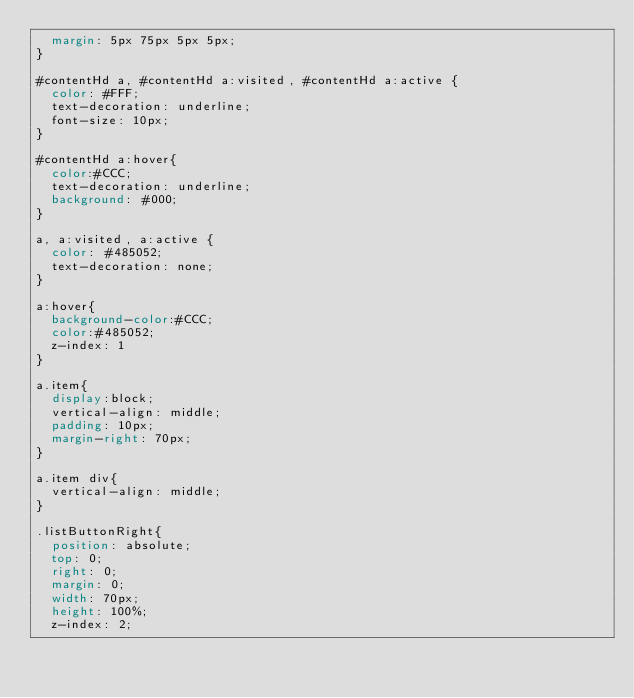Convert code to text. <code><loc_0><loc_0><loc_500><loc_500><_CSS_>	margin: 5px 75px 5px 5px;
}

#contentHd a, #contentHd a:visited, #contentHd a:active {
	color: #FFF;
	text-decoration: underline;
	font-size: 10px;
}

#contentHd a:hover{
	color:#CCC;
	text-decoration: underline;
	background: #000;
}

a, a:visited, a:active {
	color: #485052;
	text-decoration: none;
}

a:hover{
	background-color:#CCC;
	color:#485052;
	z-index: 1
}

a.item{
	display:block;
	vertical-align: middle;
	padding: 10px;
	margin-right: 70px;
}

a.item div{
	vertical-align: middle;
}

.listButtonRight{
	position: absolute;
	top: 0;
	right: 0;
	margin: 0;
	width: 70px;
	height: 100%;
	z-index: 2;</code> 